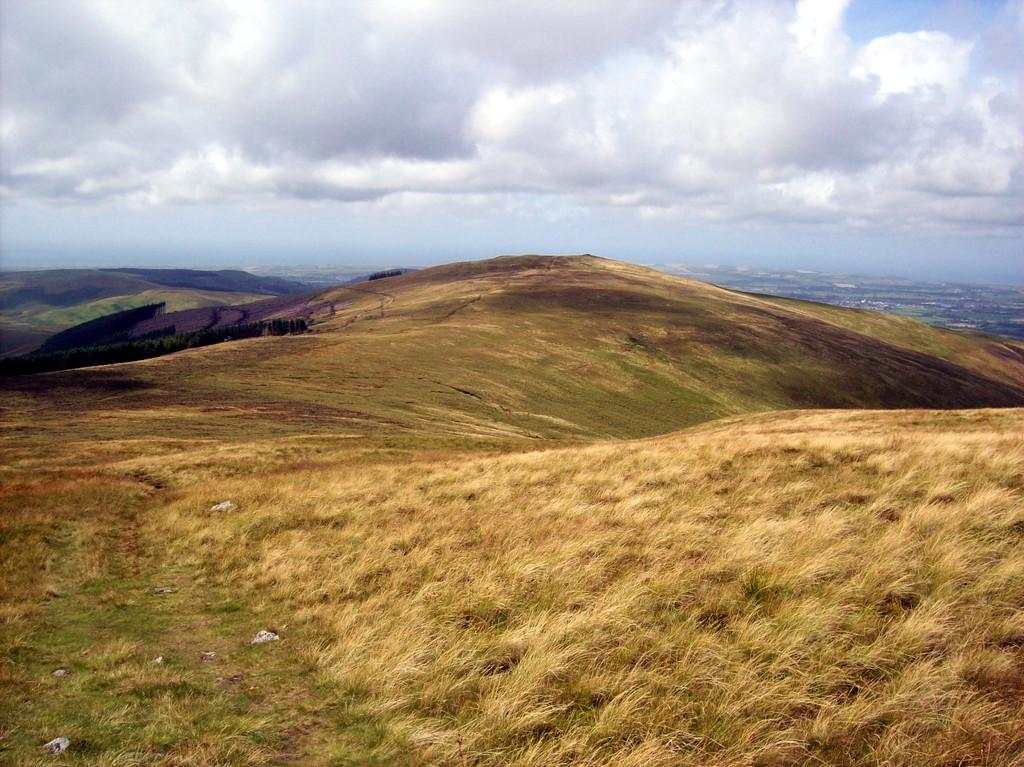What type of setting is depicted in the image? The image is an outside view. What type of ground surface can be seen in the image? There is grass on the ground in the image. What geographical features are visible in the image? There are hills visible in the image. What is visible at the top of the image? The sky is visible at the top of the image. What can be observed in the sky in the image? Clouds are present in the sky. What type of window can be seen in the image? There is no window present in the image, as it is an outside view. 